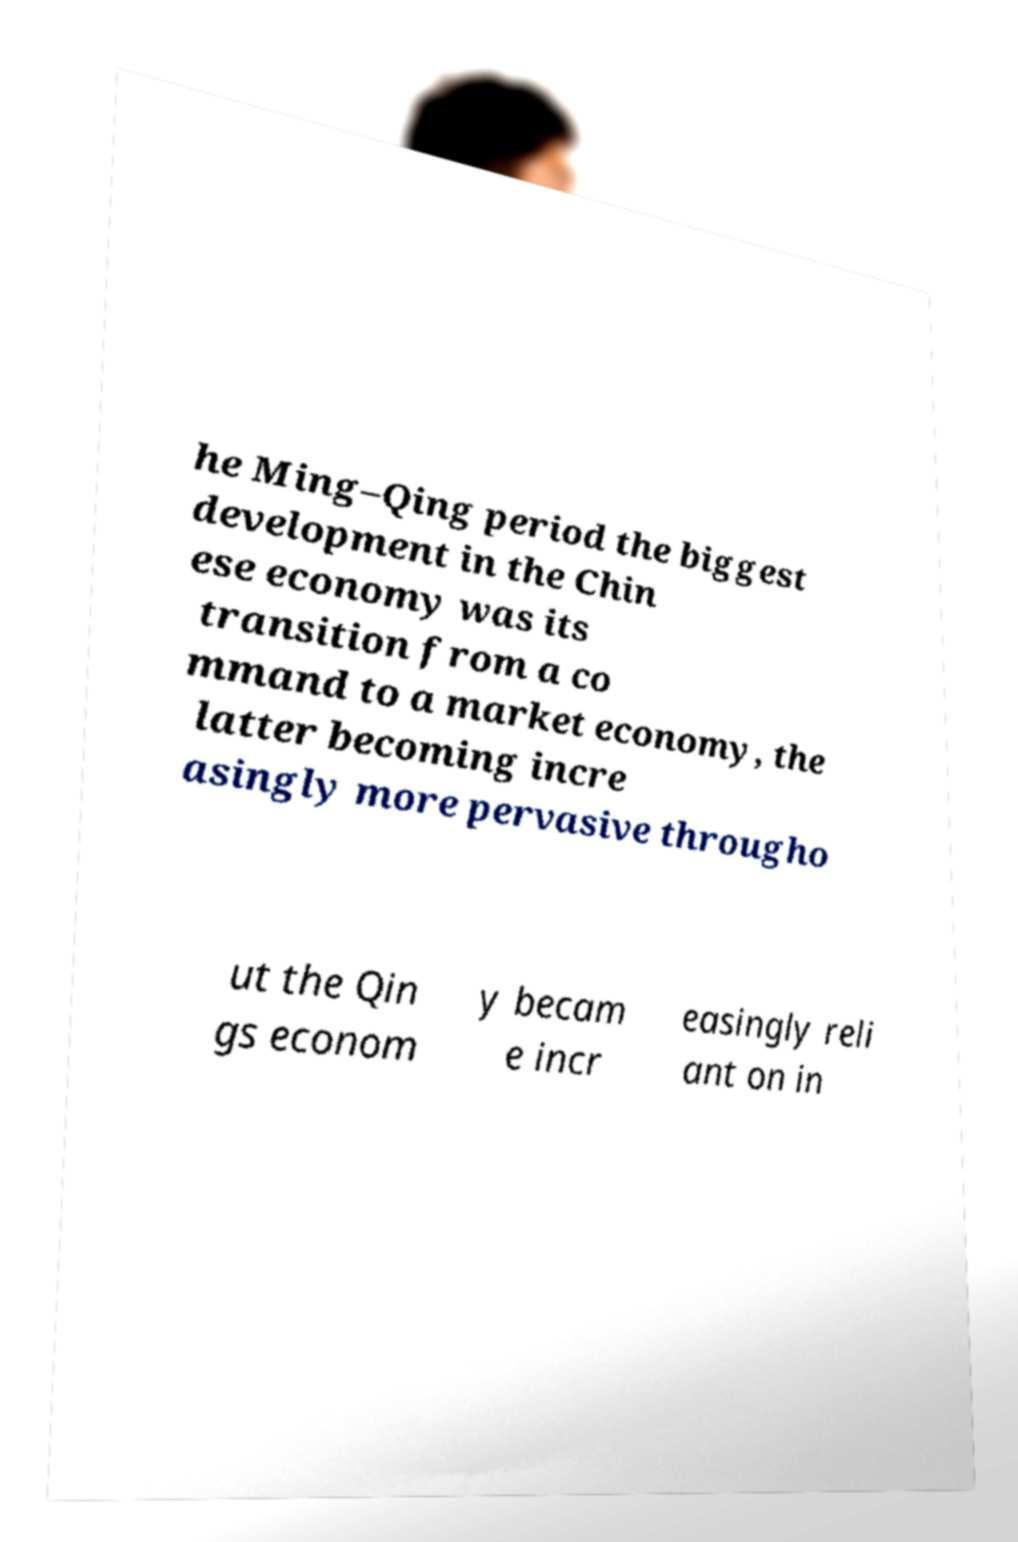Can you accurately transcribe the text from the provided image for me? he Ming–Qing period the biggest development in the Chin ese economy was its transition from a co mmand to a market economy, the latter becoming incre asingly more pervasive througho ut the Qin gs econom y becam e incr easingly reli ant on in 